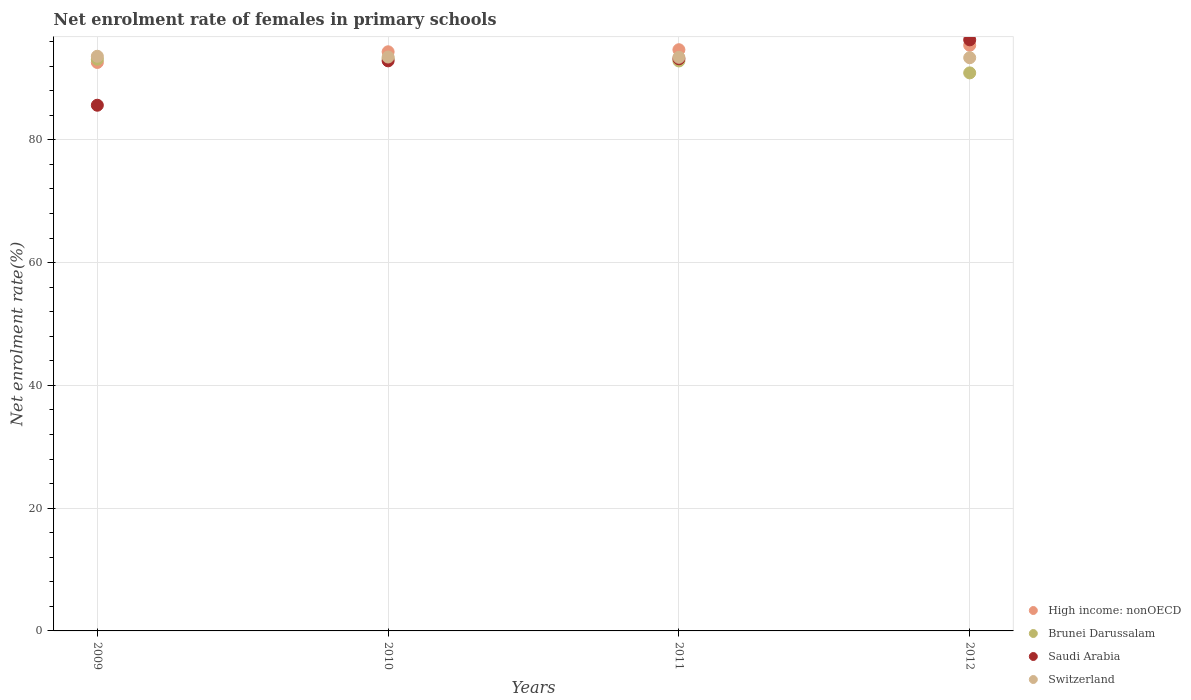How many different coloured dotlines are there?
Your response must be concise. 4. Is the number of dotlines equal to the number of legend labels?
Offer a terse response. Yes. What is the net enrolment rate of females in primary schools in Saudi Arabia in 2010?
Offer a very short reply. 92.86. Across all years, what is the maximum net enrolment rate of females in primary schools in Switzerland?
Make the answer very short. 93.6. Across all years, what is the minimum net enrolment rate of females in primary schools in Switzerland?
Make the answer very short. 93.37. In which year was the net enrolment rate of females in primary schools in Switzerland maximum?
Ensure brevity in your answer.  2009. In which year was the net enrolment rate of females in primary schools in Brunei Darussalam minimum?
Provide a succinct answer. 2012. What is the total net enrolment rate of females in primary schools in Saudi Arabia in the graph?
Provide a short and direct response. 367.94. What is the difference between the net enrolment rate of females in primary schools in High income: nonOECD in 2011 and that in 2012?
Provide a succinct answer. -0.72. What is the difference between the net enrolment rate of females in primary schools in Brunei Darussalam in 2011 and the net enrolment rate of females in primary schools in Saudi Arabia in 2009?
Offer a very short reply. 7.21. What is the average net enrolment rate of females in primary schools in High income: nonOECD per year?
Your answer should be very brief. 94.24. In the year 2010, what is the difference between the net enrolment rate of females in primary schools in High income: nonOECD and net enrolment rate of females in primary schools in Brunei Darussalam?
Your response must be concise. 1.13. What is the ratio of the net enrolment rate of females in primary schools in Brunei Darussalam in 2011 to that in 2012?
Ensure brevity in your answer.  1.02. Is the net enrolment rate of females in primary schools in Brunei Darussalam in 2009 less than that in 2011?
Your answer should be very brief. No. What is the difference between the highest and the second highest net enrolment rate of females in primary schools in Switzerland?
Provide a succinct answer. 0.12. What is the difference between the highest and the lowest net enrolment rate of females in primary schools in High income: nonOECD?
Give a very brief answer. 2.8. Is the sum of the net enrolment rate of females in primary schools in Switzerland in 2010 and 2011 greater than the maximum net enrolment rate of females in primary schools in Saudi Arabia across all years?
Your answer should be compact. Yes. Is it the case that in every year, the sum of the net enrolment rate of females in primary schools in Saudi Arabia and net enrolment rate of females in primary schools in Brunei Darussalam  is greater than the sum of net enrolment rate of females in primary schools in Switzerland and net enrolment rate of females in primary schools in High income: nonOECD?
Your answer should be compact. No. Does the net enrolment rate of females in primary schools in Saudi Arabia monotonically increase over the years?
Offer a very short reply. Yes. Is the net enrolment rate of females in primary schools in Switzerland strictly less than the net enrolment rate of females in primary schools in High income: nonOECD over the years?
Provide a succinct answer. No. How many years are there in the graph?
Provide a succinct answer. 4. Are the values on the major ticks of Y-axis written in scientific E-notation?
Give a very brief answer. No. Does the graph contain grids?
Make the answer very short. Yes. How are the legend labels stacked?
Make the answer very short. Vertical. What is the title of the graph?
Your answer should be very brief. Net enrolment rate of females in primary schools. What is the label or title of the X-axis?
Offer a terse response. Years. What is the label or title of the Y-axis?
Provide a short and direct response. Net enrolment rate(%). What is the Net enrolment rate(%) of High income: nonOECD in 2009?
Offer a terse response. 92.59. What is the Net enrolment rate(%) of Brunei Darussalam in 2009?
Your answer should be very brief. 93.12. What is the Net enrolment rate(%) of Saudi Arabia in 2009?
Provide a short and direct response. 85.63. What is the Net enrolment rate(%) of Switzerland in 2009?
Give a very brief answer. 93.6. What is the Net enrolment rate(%) of High income: nonOECD in 2010?
Your response must be concise. 94.33. What is the Net enrolment rate(%) in Brunei Darussalam in 2010?
Offer a terse response. 93.2. What is the Net enrolment rate(%) in Saudi Arabia in 2010?
Provide a succinct answer. 92.86. What is the Net enrolment rate(%) of Switzerland in 2010?
Offer a very short reply. 93.48. What is the Net enrolment rate(%) in High income: nonOECD in 2011?
Your answer should be compact. 94.67. What is the Net enrolment rate(%) of Brunei Darussalam in 2011?
Make the answer very short. 92.84. What is the Net enrolment rate(%) in Saudi Arabia in 2011?
Provide a short and direct response. 93.19. What is the Net enrolment rate(%) of Switzerland in 2011?
Provide a succinct answer. 93.43. What is the Net enrolment rate(%) in High income: nonOECD in 2012?
Your answer should be compact. 95.39. What is the Net enrolment rate(%) in Brunei Darussalam in 2012?
Ensure brevity in your answer.  90.89. What is the Net enrolment rate(%) in Saudi Arabia in 2012?
Keep it short and to the point. 96.28. What is the Net enrolment rate(%) of Switzerland in 2012?
Ensure brevity in your answer.  93.37. Across all years, what is the maximum Net enrolment rate(%) of High income: nonOECD?
Offer a very short reply. 95.39. Across all years, what is the maximum Net enrolment rate(%) of Brunei Darussalam?
Ensure brevity in your answer.  93.2. Across all years, what is the maximum Net enrolment rate(%) in Saudi Arabia?
Provide a succinct answer. 96.28. Across all years, what is the maximum Net enrolment rate(%) of Switzerland?
Give a very brief answer. 93.6. Across all years, what is the minimum Net enrolment rate(%) of High income: nonOECD?
Make the answer very short. 92.59. Across all years, what is the minimum Net enrolment rate(%) of Brunei Darussalam?
Your response must be concise. 90.89. Across all years, what is the minimum Net enrolment rate(%) in Saudi Arabia?
Your answer should be very brief. 85.63. Across all years, what is the minimum Net enrolment rate(%) in Switzerland?
Offer a terse response. 93.37. What is the total Net enrolment rate(%) in High income: nonOECD in the graph?
Make the answer very short. 376.98. What is the total Net enrolment rate(%) of Brunei Darussalam in the graph?
Your answer should be compact. 370.05. What is the total Net enrolment rate(%) in Saudi Arabia in the graph?
Ensure brevity in your answer.  367.94. What is the total Net enrolment rate(%) of Switzerland in the graph?
Your answer should be very brief. 373.88. What is the difference between the Net enrolment rate(%) in High income: nonOECD in 2009 and that in 2010?
Keep it short and to the point. -1.74. What is the difference between the Net enrolment rate(%) of Brunei Darussalam in 2009 and that in 2010?
Offer a terse response. -0.08. What is the difference between the Net enrolment rate(%) of Saudi Arabia in 2009 and that in 2010?
Your answer should be compact. -7.23. What is the difference between the Net enrolment rate(%) of Switzerland in 2009 and that in 2010?
Keep it short and to the point. 0.12. What is the difference between the Net enrolment rate(%) in High income: nonOECD in 2009 and that in 2011?
Offer a terse response. -2.08. What is the difference between the Net enrolment rate(%) of Brunei Darussalam in 2009 and that in 2011?
Provide a succinct answer. 0.28. What is the difference between the Net enrolment rate(%) of Saudi Arabia in 2009 and that in 2011?
Your answer should be compact. -7.56. What is the difference between the Net enrolment rate(%) of Switzerland in 2009 and that in 2011?
Provide a succinct answer. 0.17. What is the difference between the Net enrolment rate(%) in High income: nonOECD in 2009 and that in 2012?
Keep it short and to the point. -2.8. What is the difference between the Net enrolment rate(%) in Brunei Darussalam in 2009 and that in 2012?
Your response must be concise. 2.23. What is the difference between the Net enrolment rate(%) in Saudi Arabia in 2009 and that in 2012?
Your answer should be compact. -10.65. What is the difference between the Net enrolment rate(%) in Switzerland in 2009 and that in 2012?
Offer a very short reply. 0.24. What is the difference between the Net enrolment rate(%) of High income: nonOECD in 2010 and that in 2011?
Provide a succinct answer. -0.34. What is the difference between the Net enrolment rate(%) in Brunei Darussalam in 2010 and that in 2011?
Provide a short and direct response. 0.36. What is the difference between the Net enrolment rate(%) in Saudi Arabia in 2010 and that in 2011?
Your answer should be compact. -0.33. What is the difference between the Net enrolment rate(%) in Switzerland in 2010 and that in 2011?
Keep it short and to the point. 0.05. What is the difference between the Net enrolment rate(%) in High income: nonOECD in 2010 and that in 2012?
Provide a succinct answer. -1.06. What is the difference between the Net enrolment rate(%) in Brunei Darussalam in 2010 and that in 2012?
Provide a short and direct response. 2.31. What is the difference between the Net enrolment rate(%) in Saudi Arabia in 2010 and that in 2012?
Ensure brevity in your answer.  -3.42. What is the difference between the Net enrolment rate(%) of Switzerland in 2010 and that in 2012?
Your answer should be compact. 0.12. What is the difference between the Net enrolment rate(%) in High income: nonOECD in 2011 and that in 2012?
Offer a terse response. -0.72. What is the difference between the Net enrolment rate(%) in Brunei Darussalam in 2011 and that in 2012?
Ensure brevity in your answer.  1.95. What is the difference between the Net enrolment rate(%) of Saudi Arabia in 2011 and that in 2012?
Your response must be concise. -3.09. What is the difference between the Net enrolment rate(%) of Switzerland in 2011 and that in 2012?
Offer a terse response. 0.06. What is the difference between the Net enrolment rate(%) in High income: nonOECD in 2009 and the Net enrolment rate(%) in Brunei Darussalam in 2010?
Keep it short and to the point. -0.61. What is the difference between the Net enrolment rate(%) of High income: nonOECD in 2009 and the Net enrolment rate(%) of Saudi Arabia in 2010?
Your answer should be very brief. -0.26. What is the difference between the Net enrolment rate(%) of High income: nonOECD in 2009 and the Net enrolment rate(%) of Switzerland in 2010?
Give a very brief answer. -0.89. What is the difference between the Net enrolment rate(%) of Brunei Darussalam in 2009 and the Net enrolment rate(%) of Saudi Arabia in 2010?
Your response must be concise. 0.26. What is the difference between the Net enrolment rate(%) in Brunei Darussalam in 2009 and the Net enrolment rate(%) in Switzerland in 2010?
Offer a very short reply. -0.36. What is the difference between the Net enrolment rate(%) of Saudi Arabia in 2009 and the Net enrolment rate(%) of Switzerland in 2010?
Your answer should be compact. -7.86. What is the difference between the Net enrolment rate(%) in High income: nonOECD in 2009 and the Net enrolment rate(%) in Brunei Darussalam in 2011?
Provide a short and direct response. -0.25. What is the difference between the Net enrolment rate(%) of High income: nonOECD in 2009 and the Net enrolment rate(%) of Saudi Arabia in 2011?
Keep it short and to the point. -0.6. What is the difference between the Net enrolment rate(%) in High income: nonOECD in 2009 and the Net enrolment rate(%) in Switzerland in 2011?
Ensure brevity in your answer.  -0.84. What is the difference between the Net enrolment rate(%) of Brunei Darussalam in 2009 and the Net enrolment rate(%) of Saudi Arabia in 2011?
Provide a succinct answer. -0.07. What is the difference between the Net enrolment rate(%) of Brunei Darussalam in 2009 and the Net enrolment rate(%) of Switzerland in 2011?
Your answer should be very brief. -0.31. What is the difference between the Net enrolment rate(%) in Saudi Arabia in 2009 and the Net enrolment rate(%) in Switzerland in 2011?
Ensure brevity in your answer.  -7.8. What is the difference between the Net enrolment rate(%) in High income: nonOECD in 2009 and the Net enrolment rate(%) in Brunei Darussalam in 2012?
Make the answer very short. 1.7. What is the difference between the Net enrolment rate(%) of High income: nonOECD in 2009 and the Net enrolment rate(%) of Saudi Arabia in 2012?
Offer a very short reply. -3.68. What is the difference between the Net enrolment rate(%) in High income: nonOECD in 2009 and the Net enrolment rate(%) in Switzerland in 2012?
Your response must be concise. -0.77. What is the difference between the Net enrolment rate(%) of Brunei Darussalam in 2009 and the Net enrolment rate(%) of Saudi Arabia in 2012?
Give a very brief answer. -3.16. What is the difference between the Net enrolment rate(%) in Brunei Darussalam in 2009 and the Net enrolment rate(%) in Switzerland in 2012?
Make the answer very short. -0.25. What is the difference between the Net enrolment rate(%) in Saudi Arabia in 2009 and the Net enrolment rate(%) in Switzerland in 2012?
Offer a terse response. -7.74. What is the difference between the Net enrolment rate(%) in High income: nonOECD in 2010 and the Net enrolment rate(%) in Brunei Darussalam in 2011?
Your answer should be compact. 1.49. What is the difference between the Net enrolment rate(%) of High income: nonOECD in 2010 and the Net enrolment rate(%) of Saudi Arabia in 2011?
Ensure brevity in your answer.  1.14. What is the difference between the Net enrolment rate(%) in High income: nonOECD in 2010 and the Net enrolment rate(%) in Switzerland in 2011?
Provide a short and direct response. 0.9. What is the difference between the Net enrolment rate(%) in Brunei Darussalam in 2010 and the Net enrolment rate(%) in Saudi Arabia in 2011?
Provide a short and direct response. 0.01. What is the difference between the Net enrolment rate(%) in Brunei Darussalam in 2010 and the Net enrolment rate(%) in Switzerland in 2011?
Provide a short and direct response. -0.23. What is the difference between the Net enrolment rate(%) of Saudi Arabia in 2010 and the Net enrolment rate(%) of Switzerland in 2011?
Your answer should be compact. -0.57. What is the difference between the Net enrolment rate(%) of High income: nonOECD in 2010 and the Net enrolment rate(%) of Brunei Darussalam in 2012?
Your response must be concise. 3.44. What is the difference between the Net enrolment rate(%) in High income: nonOECD in 2010 and the Net enrolment rate(%) in Saudi Arabia in 2012?
Keep it short and to the point. -1.95. What is the difference between the Net enrolment rate(%) of Brunei Darussalam in 2010 and the Net enrolment rate(%) of Saudi Arabia in 2012?
Make the answer very short. -3.08. What is the difference between the Net enrolment rate(%) of Brunei Darussalam in 2010 and the Net enrolment rate(%) of Switzerland in 2012?
Make the answer very short. -0.17. What is the difference between the Net enrolment rate(%) in Saudi Arabia in 2010 and the Net enrolment rate(%) in Switzerland in 2012?
Make the answer very short. -0.51. What is the difference between the Net enrolment rate(%) in High income: nonOECD in 2011 and the Net enrolment rate(%) in Brunei Darussalam in 2012?
Provide a short and direct response. 3.77. What is the difference between the Net enrolment rate(%) of High income: nonOECD in 2011 and the Net enrolment rate(%) of Saudi Arabia in 2012?
Ensure brevity in your answer.  -1.61. What is the difference between the Net enrolment rate(%) in High income: nonOECD in 2011 and the Net enrolment rate(%) in Switzerland in 2012?
Your response must be concise. 1.3. What is the difference between the Net enrolment rate(%) in Brunei Darussalam in 2011 and the Net enrolment rate(%) in Saudi Arabia in 2012?
Ensure brevity in your answer.  -3.44. What is the difference between the Net enrolment rate(%) of Brunei Darussalam in 2011 and the Net enrolment rate(%) of Switzerland in 2012?
Provide a short and direct response. -0.53. What is the difference between the Net enrolment rate(%) in Saudi Arabia in 2011 and the Net enrolment rate(%) in Switzerland in 2012?
Provide a succinct answer. -0.18. What is the average Net enrolment rate(%) in High income: nonOECD per year?
Provide a short and direct response. 94.24. What is the average Net enrolment rate(%) of Brunei Darussalam per year?
Give a very brief answer. 92.51. What is the average Net enrolment rate(%) of Saudi Arabia per year?
Your response must be concise. 91.99. What is the average Net enrolment rate(%) of Switzerland per year?
Offer a very short reply. 93.47. In the year 2009, what is the difference between the Net enrolment rate(%) in High income: nonOECD and Net enrolment rate(%) in Brunei Darussalam?
Provide a short and direct response. -0.53. In the year 2009, what is the difference between the Net enrolment rate(%) of High income: nonOECD and Net enrolment rate(%) of Saudi Arabia?
Give a very brief answer. 6.97. In the year 2009, what is the difference between the Net enrolment rate(%) in High income: nonOECD and Net enrolment rate(%) in Switzerland?
Ensure brevity in your answer.  -1.01. In the year 2009, what is the difference between the Net enrolment rate(%) in Brunei Darussalam and Net enrolment rate(%) in Saudi Arabia?
Your answer should be very brief. 7.49. In the year 2009, what is the difference between the Net enrolment rate(%) of Brunei Darussalam and Net enrolment rate(%) of Switzerland?
Offer a very short reply. -0.48. In the year 2009, what is the difference between the Net enrolment rate(%) of Saudi Arabia and Net enrolment rate(%) of Switzerland?
Keep it short and to the point. -7.98. In the year 2010, what is the difference between the Net enrolment rate(%) of High income: nonOECD and Net enrolment rate(%) of Brunei Darussalam?
Your answer should be compact. 1.13. In the year 2010, what is the difference between the Net enrolment rate(%) in High income: nonOECD and Net enrolment rate(%) in Saudi Arabia?
Give a very brief answer. 1.48. In the year 2010, what is the difference between the Net enrolment rate(%) of High income: nonOECD and Net enrolment rate(%) of Switzerland?
Provide a succinct answer. 0.85. In the year 2010, what is the difference between the Net enrolment rate(%) of Brunei Darussalam and Net enrolment rate(%) of Saudi Arabia?
Provide a short and direct response. 0.34. In the year 2010, what is the difference between the Net enrolment rate(%) of Brunei Darussalam and Net enrolment rate(%) of Switzerland?
Offer a very short reply. -0.28. In the year 2010, what is the difference between the Net enrolment rate(%) of Saudi Arabia and Net enrolment rate(%) of Switzerland?
Provide a short and direct response. -0.63. In the year 2011, what is the difference between the Net enrolment rate(%) in High income: nonOECD and Net enrolment rate(%) in Brunei Darussalam?
Your answer should be very brief. 1.83. In the year 2011, what is the difference between the Net enrolment rate(%) of High income: nonOECD and Net enrolment rate(%) of Saudi Arabia?
Provide a succinct answer. 1.48. In the year 2011, what is the difference between the Net enrolment rate(%) of High income: nonOECD and Net enrolment rate(%) of Switzerland?
Offer a terse response. 1.24. In the year 2011, what is the difference between the Net enrolment rate(%) in Brunei Darussalam and Net enrolment rate(%) in Saudi Arabia?
Your answer should be compact. -0.35. In the year 2011, what is the difference between the Net enrolment rate(%) of Brunei Darussalam and Net enrolment rate(%) of Switzerland?
Your response must be concise. -0.59. In the year 2011, what is the difference between the Net enrolment rate(%) of Saudi Arabia and Net enrolment rate(%) of Switzerland?
Give a very brief answer. -0.24. In the year 2012, what is the difference between the Net enrolment rate(%) of High income: nonOECD and Net enrolment rate(%) of Brunei Darussalam?
Your answer should be very brief. 4.5. In the year 2012, what is the difference between the Net enrolment rate(%) of High income: nonOECD and Net enrolment rate(%) of Saudi Arabia?
Offer a terse response. -0.89. In the year 2012, what is the difference between the Net enrolment rate(%) of High income: nonOECD and Net enrolment rate(%) of Switzerland?
Make the answer very short. 2.02. In the year 2012, what is the difference between the Net enrolment rate(%) of Brunei Darussalam and Net enrolment rate(%) of Saudi Arabia?
Keep it short and to the point. -5.38. In the year 2012, what is the difference between the Net enrolment rate(%) of Brunei Darussalam and Net enrolment rate(%) of Switzerland?
Offer a terse response. -2.47. In the year 2012, what is the difference between the Net enrolment rate(%) of Saudi Arabia and Net enrolment rate(%) of Switzerland?
Offer a terse response. 2.91. What is the ratio of the Net enrolment rate(%) in High income: nonOECD in 2009 to that in 2010?
Your response must be concise. 0.98. What is the ratio of the Net enrolment rate(%) in Saudi Arabia in 2009 to that in 2010?
Give a very brief answer. 0.92. What is the ratio of the Net enrolment rate(%) of High income: nonOECD in 2009 to that in 2011?
Your answer should be compact. 0.98. What is the ratio of the Net enrolment rate(%) of Saudi Arabia in 2009 to that in 2011?
Your answer should be very brief. 0.92. What is the ratio of the Net enrolment rate(%) in High income: nonOECD in 2009 to that in 2012?
Ensure brevity in your answer.  0.97. What is the ratio of the Net enrolment rate(%) of Brunei Darussalam in 2009 to that in 2012?
Your answer should be very brief. 1.02. What is the ratio of the Net enrolment rate(%) in Saudi Arabia in 2009 to that in 2012?
Make the answer very short. 0.89. What is the ratio of the Net enrolment rate(%) in Switzerland in 2009 to that in 2012?
Your response must be concise. 1. What is the ratio of the Net enrolment rate(%) of Brunei Darussalam in 2010 to that in 2011?
Your answer should be very brief. 1. What is the ratio of the Net enrolment rate(%) in Saudi Arabia in 2010 to that in 2011?
Your answer should be very brief. 1. What is the ratio of the Net enrolment rate(%) of High income: nonOECD in 2010 to that in 2012?
Your answer should be compact. 0.99. What is the ratio of the Net enrolment rate(%) in Brunei Darussalam in 2010 to that in 2012?
Keep it short and to the point. 1.03. What is the ratio of the Net enrolment rate(%) in Saudi Arabia in 2010 to that in 2012?
Provide a short and direct response. 0.96. What is the ratio of the Net enrolment rate(%) in Brunei Darussalam in 2011 to that in 2012?
Give a very brief answer. 1.02. What is the ratio of the Net enrolment rate(%) in Saudi Arabia in 2011 to that in 2012?
Provide a short and direct response. 0.97. What is the ratio of the Net enrolment rate(%) in Switzerland in 2011 to that in 2012?
Your answer should be very brief. 1. What is the difference between the highest and the second highest Net enrolment rate(%) in High income: nonOECD?
Your answer should be compact. 0.72. What is the difference between the highest and the second highest Net enrolment rate(%) in Brunei Darussalam?
Your answer should be very brief. 0.08. What is the difference between the highest and the second highest Net enrolment rate(%) in Saudi Arabia?
Your response must be concise. 3.09. What is the difference between the highest and the second highest Net enrolment rate(%) in Switzerland?
Make the answer very short. 0.12. What is the difference between the highest and the lowest Net enrolment rate(%) of High income: nonOECD?
Keep it short and to the point. 2.8. What is the difference between the highest and the lowest Net enrolment rate(%) of Brunei Darussalam?
Keep it short and to the point. 2.31. What is the difference between the highest and the lowest Net enrolment rate(%) of Saudi Arabia?
Keep it short and to the point. 10.65. What is the difference between the highest and the lowest Net enrolment rate(%) in Switzerland?
Make the answer very short. 0.24. 